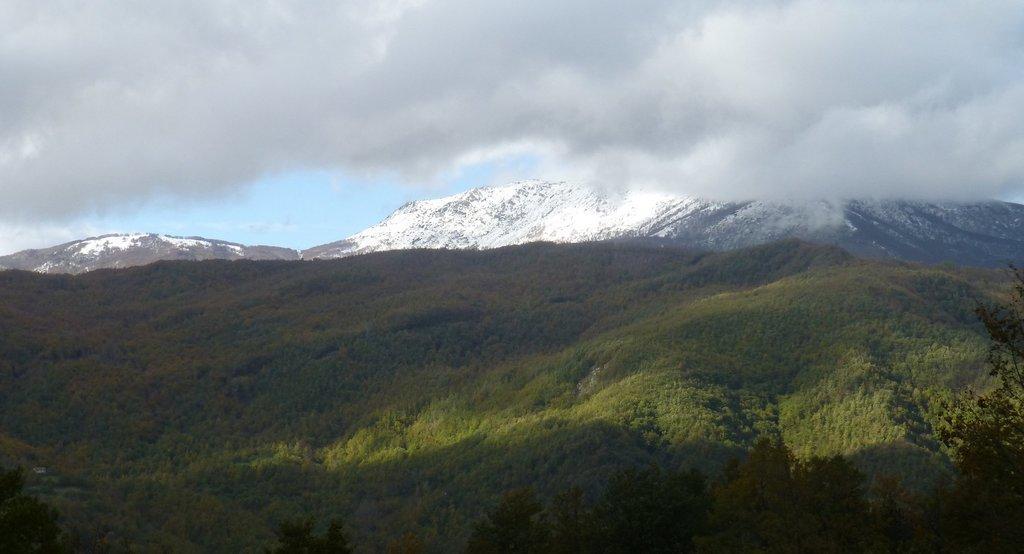Can you describe this image briefly? In this image I can see at the bottom there are trees, in the background there are hills with the snow, at the top it is the cloudy sky. 